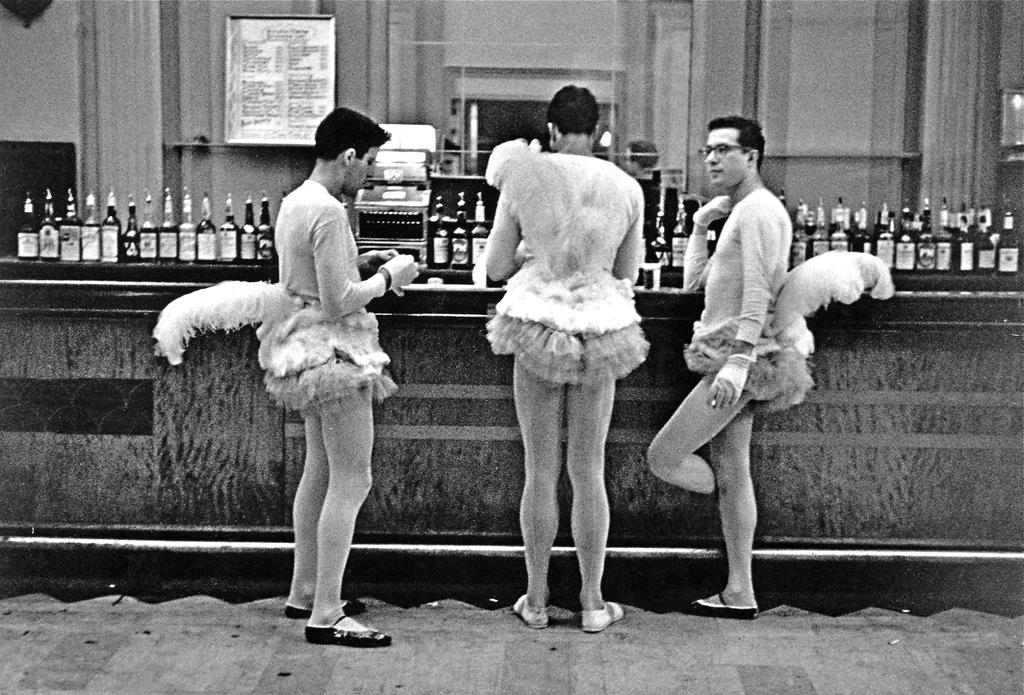How many people are in the image? There are three persons in the image. What are the persons wearing? The persons are wearing forks (possibly a typo, should be "forks"). Where are the persons standing in relation to the table? The persons are standing in front of a table. What can be seen on the table? There are bottles on the table. What is visible at the top of the image? There is a wall visible at the top of the image. What type of thought can be seen expanding in the image? There is no thought or expansion present in the image; it features three persons standing in front of a table with bottles on it. Can you see a monkey interacting with the persons in the image? There is no monkey present in the image. 